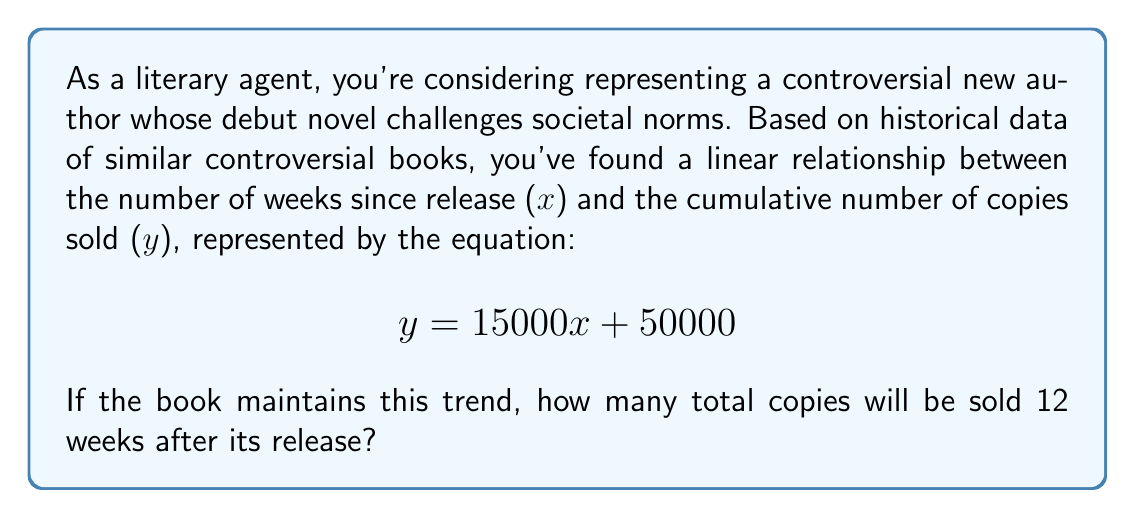Can you solve this math problem? To solve this problem, we'll use the given linear equation and substitute the known value for $x$ (number of weeks) to find $y$ (cumulative number of copies sold).

Given:
- Linear equation: $y = 15000x + 50000$
- Weeks since release: $x = 12$

Step 1: Substitute $x = 12$ into the equation.
$$y = 15000(12) + 50000$$

Step 2: Simplify the multiplication.
$$y = 180000 + 50000$$

Step 3: Add the numbers to get the final result.
$$y = 230000$$

Therefore, 12 weeks after its release, the controversial book is predicted to sell a total of 230,000 copies.
Answer: 230,000 copies 